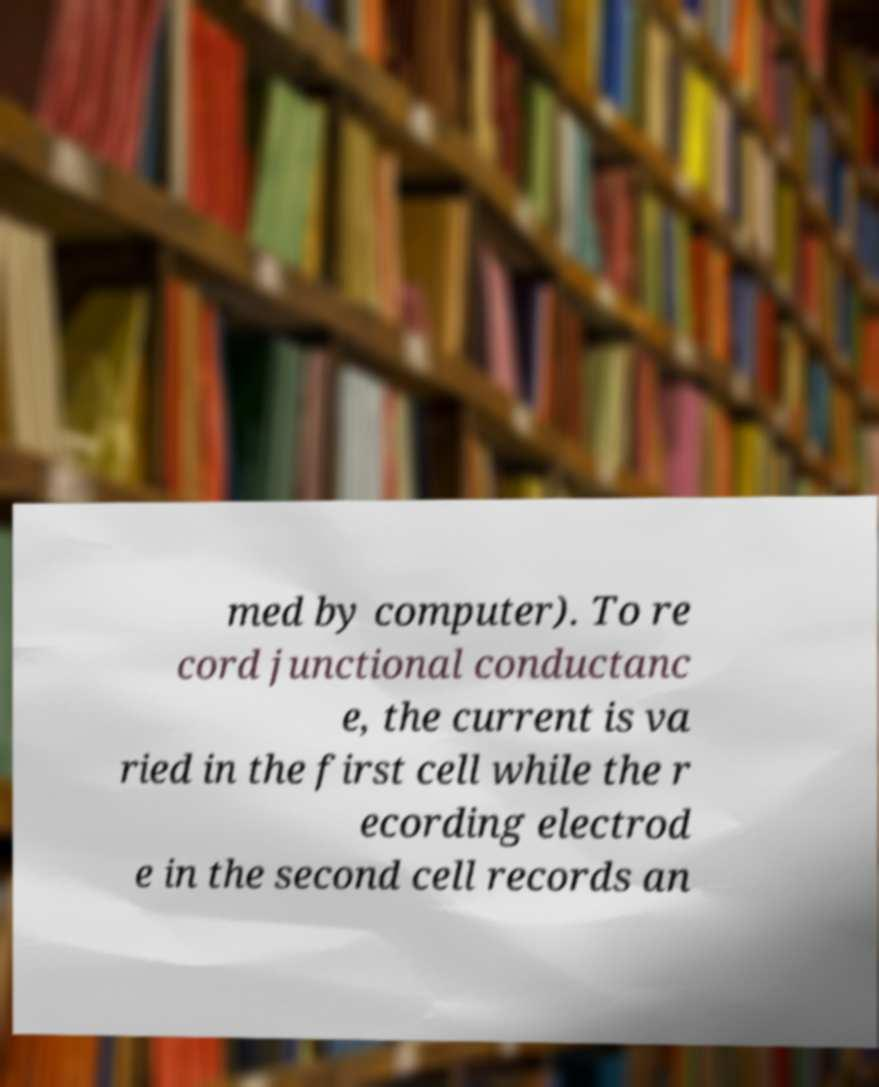There's text embedded in this image that I need extracted. Can you transcribe it verbatim? med by computer). To re cord junctional conductanc e, the current is va ried in the first cell while the r ecording electrod e in the second cell records an 